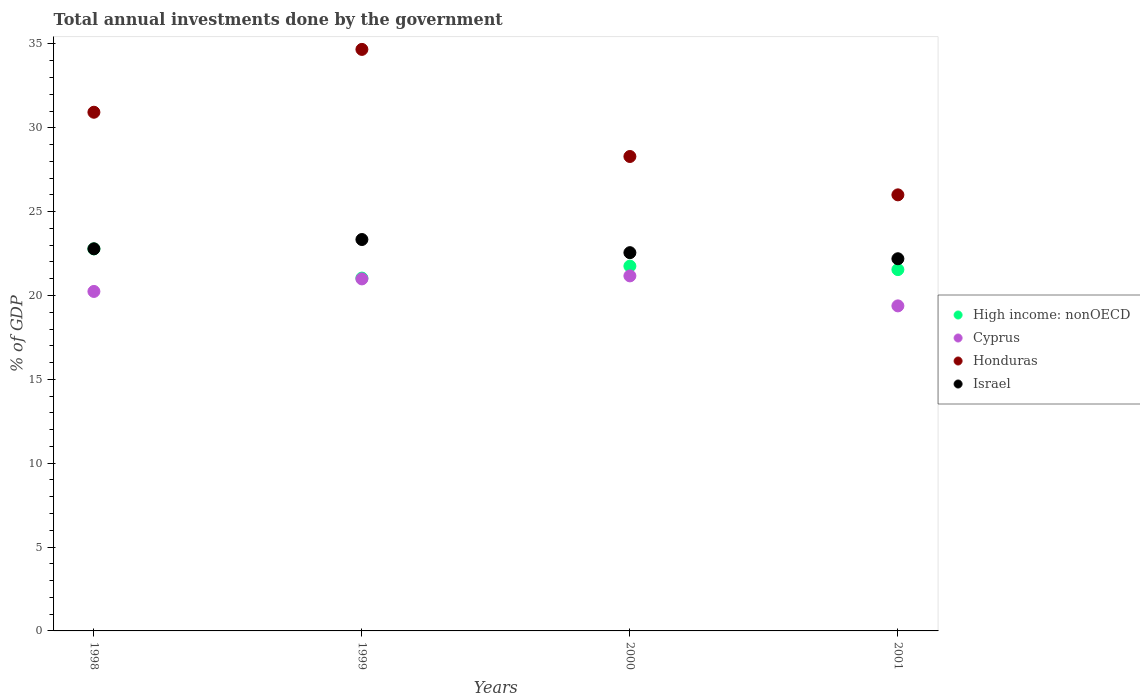What is the total annual investments done by the government in High income: nonOECD in 1999?
Ensure brevity in your answer.  21.04. Across all years, what is the maximum total annual investments done by the government in Israel?
Your answer should be very brief. 23.34. Across all years, what is the minimum total annual investments done by the government in Honduras?
Make the answer very short. 26. What is the total total annual investments done by the government in Israel in the graph?
Your response must be concise. 90.87. What is the difference between the total annual investments done by the government in Honduras in 1999 and that in 2001?
Make the answer very short. 8.67. What is the difference between the total annual investments done by the government in Honduras in 1998 and the total annual investments done by the government in Cyprus in 2000?
Your response must be concise. 9.76. What is the average total annual investments done by the government in Honduras per year?
Offer a terse response. 29.97. In the year 2000, what is the difference between the total annual investments done by the government in Honduras and total annual investments done by the government in Cyprus?
Provide a succinct answer. 7.12. In how many years, is the total annual investments done by the government in High income: nonOECD greater than 29 %?
Your response must be concise. 0. What is the ratio of the total annual investments done by the government in Honduras in 2000 to that in 2001?
Offer a terse response. 1.09. What is the difference between the highest and the second highest total annual investments done by the government in Honduras?
Your answer should be compact. 3.75. What is the difference between the highest and the lowest total annual investments done by the government in Israel?
Offer a terse response. 1.15. Is it the case that in every year, the sum of the total annual investments done by the government in High income: nonOECD and total annual investments done by the government in Israel  is greater than the sum of total annual investments done by the government in Honduras and total annual investments done by the government in Cyprus?
Your answer should be very brief. Yes. Does the total annual investments done by the government in High income: nonOECD monotonically increase over the years?
Offer a terse response. No. Is the total annual investments done by the government in Cyprus strictly greater than the total annual investments done by the government in Israel over the years?
Your response must be concise. No. Is the total annual investments done by the government in High income: nonOECD strictly less than the total annual investments done by the government in Israel over the years?
Offer a very short reply. Yes. How many years are there in the graph?
Provide a succinct answer. 4. What is the difference between two consecutive major ticks on the Y-axis?
Your answer should be very brief. 5. Are the values on the major ticks of Y-axis written in scientific E-notation?
Your response must be concise. No. What is the title of the graph?
Offer a terse response. Total annual investments done by the government. Does "Andorra" appear as one of the legend labels in the graph?
Your answer should be very brief. No. What is the label or title of the X-axis?
Offer a very short reply. Years. What is the label or title of the Y-axis?
Ensure brevity in your answer.  % of GDP. What is the % of GDP of High income: nonOECD in 1998?
Your answer should be very brief. 22.78. What is the % of GDP of Cyprus in 1998?
Your answer should be compact. 20.24. What is the % of GDP of Honduras in 1998?
Make the answer very short. 30.93. What is the % of GDP in Israel in 1998?
Make the answer very short. 22.78. What is the % of GDP in High income: nonOECD in 1999?
Give a very brief answer. 21.04. What is the % of GDP of Cyprus in 1999?
Your answer should be compact. 20.99. What is the % of GDP in Honduras in 1999?
Offer a terse response. 34.67. What is the % of GDP of Israel in 1999?
Give a very brief answer. 23.34. What is the % of GDP in High income: nonOECD in 2000?
Ensure brevity in your answer.  21.75. What is the % of GDP in Cyprus in 2000?
Ensure brevity in your answer.  21.17. What is the % of GDP of Honduras in 2000?
Provide a short and direct response. 28.29. What is the % of GDP in Israel in 2000?
Give a very brief answer. 22.55. What is the % of GDP in High income: nonOECD in 2001?
Your answer should be very brief. 21.54. What is the % of GDP in Cyprus in 2001?
Offer a very short reply. 19.38. What is the % of GDP in Honduras in 2001?
Keep it short and to the point. 26. What is the % of GDP of Israel in 2001?
Make the answer very short. 22.19. Across all years, what is the maximum % of GDP of High income: nonOECD?
Your answer should be very brief. 22.78. Across all years, what is the maximum % of GDP of Cyprus?
Give a very brief answer. 21.17. Across all years, what is the maximum % of GDP in Honduras?
Ensure brevity in your answer.  34.67. Across all years, what is the maximum % of GDP in Israel?
Provide a short and direct response. 23.34. Across all years, what is the minimum % of GDP in High income: nonOECD?
Your answer should be compact. 21.04. Across all years, what is the minimum % of GDP in Cyprus?
Your response must be concise. 19.38. Across all years, what is the minimum % of GDP of Honduras?
Your response must be concise. 26. Across all years, what is the minimum % of GDP of Israel?
Your response must be concise. 22.19. What is the total % of GDP in High income: nonOECD in the graph?
Ensure brevity in your answer.  87.11. What is the total % of GDP in Cyprus in the graph?
Offer a very short reply. 81.78. What is the total % of GDP in Honduras in the graph?
Offer a very short reply. 119.89. What is the total % of GDP in Israel in the graph?
Ensure brevity in your answer.  90.87. What is the difference between the % of GDP in High income: nonOECD in 1998 and that in 1999?
Provide a succinct answer. 1.74. What is the difference between the % of GDP of Cyprus in 1998 and that in 1999?
Your answer should be very brief. -0.75. What is the difference between the % of GDP in Honduras in 1998 and that in 1999?
Ensure brevity in your answer.  -3.75. What is the difference between the % of GDP in Israel in 1998 and that in 1999?
Your answer should be very brief. -0.55. What is the difference between the % of GDP in High income: nonOECD in 1998 and that in 2000?
Keep it short and to the point. 1.03. What is the difference between the % of GDP of Cyprus in 1998 and that in 2000?
Keep it short and to the point. -0.93. What is the difference between the % of GDP of Honduras in 1998 and that in 2000?
Ensure brevity in your answer.  2.64. What is the difference between the % of GDP of Israel in 1998 and that in 2000?
Ensure brevity in your answer.  0.23. What is the difference between the % of GDP of High income: nonOECD in 1998 and that in 2001?
Give a very brief answer. 1.23. What is the difference between the % of GDP of Cyprus in 1998 and that in 2001?
Provide a short and direct response. 0.86. What is the difference between the % of GDP in Honduras in 1998 and that in 2001?
Offer a terse response. 4.93. What is the difference between the % of GDP in Israel in 1998 and that in 2001?
Provide a succinct answer. 0.59. What is the difference between the % of GDP in High income: nonOECD in 1999 and that in 2000?
Keep it short and to the point. -0.71. What is the difference between the % of GDP of Cyprus in 1999 and that in 2000?
Give a very brief answer. -0.18. What is the difference between the % of GDP in Honduras in 1999 and that in 2000?
Give a very brief answer. 6.39. What is the difference between the % of GDP in Israel in 1999 and that in 2000?
Give a very brief answer. 0.78. What is the difference between the % of GDP in High income: nonOECD in 1999 and that in 2001?
Make the answer very short. -0.51. What is the difference between the % of GDP of Cyprus in 1999 and that in 2001?
Provide a succinct answer. 1.61. What is the difference between the % of GDP of Honduras in 1999 and that in 2001?
Keep it short and to the point. 8.67. What is the difference between the % of GDP in Israel in 1999 and that in 2001?
Provide a short and direct response. 1.15. What is the difference between the % of GDP in High income: nonOECD in 2000 and that in 2001?
Make the answer very short. 0.21. What is the difference between the % of GDP in Cyprus in 2000 and that in 2001?
Ensure brevity in your answer.  1.79. What is the difference between the % of GDP of Honduras in 2000 and that in 2001?
Ensure brevity in your answer.  2.29. What is the difference between the % of GDP of Israel in 2000 and that in 2001?
Offer a terse response. 0.36. What is the difference between the % of GDP in High income: nonOECD in 1998 and the % of GDP in Cyprus in 1999?
Make the answer very short. 1.79. What is the difference between the % of GDP of High income: nonOECD in 1998 and the % of GDP of Honduras in 1999?
Your answer should be compact. -11.9. What is the difference between the % of GDP in High income: nonOECD in 1998 and the % of GDP in Israel in 1999?
Keep it short and to the point. -0.56. What is the difference between the % of GDP of Cyprus in 1998 and the % of GDP of Honduras in 1999?
Your response must be concise. -14.43. What is the difference between the % of GDP in Cyprus in 1998 and the % of GDP in Israel in 1999?
Provide a succinct answer. -3.1. What is the difference between the % of GDP in Honduras in 1998 and the % of GDP in Israel in 1999?
Give a very brief answer. 7.59. What is the difference between the % of GDP in High income: nonOECD in 1998 and the % of GDP in Cyprus in 2000?
Offer a very short reply. 1.61. What is the difference between the % of GDP in High income: nonOECD in 1998 and the % of GDP in Honduras in 2000?
Keep it short and to the point. -5.51. What is the difference between the % of GDP in High income: nonOECD in 1998 and the % of GDP in Israel in 2000?
Offer a very short reply. 0.22. What is the difference between the % of GDP of Cyprus in 1998 and the % of GDP of Honduras in 2000?
Your answer should be very brief. -8.05. What is the difference between the % of GDP in Cyprus in 1998 and the % of GDP in Israel in 2000?
Offer a terse response. -2.31. What is the difference between the % of GDP in Honduras in 1998 and the % of GDP in Israel in 2000?
Your answer should be very brief. 8.37. What is the difference between the % of GDP in High income: nonOECD in 1998 and the % of GDP in Cyprus in 2001?
Make the answer very short. 3.4. What is the difference between the % of GDP in High income: nonOECD in 1998 and the % of GDP in Honduras in 2001?
Your response must be concise. -3.22. What is the difference between the % of GDP in High income: nonOECD in 1998 and the % of GDP in Israel in 2001?
Your answer should be compact. 0.59. What is the difference between the % of GDP in Cyprus in 1998 and the % of GDP in Honduras in 2001?
Offer a terse response. -5.76. What is the difference between the % of GDP of Cyprus in 1998 and the % of GDP of Israel in 2001?
Make the answer very short. -1.95. What is the difference between the % of GDP in Honduras in 1998 and the % of GDP in Israel in 2001?
Provide a short and direct response. 8.74. What is the difference between the % of GDP of High income: nonOECD in 1999 and the % of GDP of Cyprus in 2000?
Your answer should be very brief. -0.13. What is the difference between the % of GDP of High income: nonOECD in 1999 and the % of GDP of Honduras in 2000?
Give a very brief answer. -7.25. What is the difference between the % of GDP of High income: nonOECD in 1999 and the % of GDP of Israel in 2000?
Your response must be concise. -1.52. What is the difference between the % of GDP of Cyprus in 1999 and the % of GDP of Honduras in 2000?
Keep it short and to the point. -7.3. What is the difference between the % of GDP of Cyprus in 1999 and the % of GDP of Israel in 2000?
Keep it short and to the point. -1.56. What is the difference between the % of GDP of Honduras in 1999 and the % of GDP of Israel in 2000?
Provide a short and direct response. 12.12. What is the difference between the % of GDP of High income: nonOECD in 1999 and the % of GDP of Cyprus in 2001?
Keep it short and to the point. 1.66. What is the difference between the % of GDP of High income: nonOECD in 1999 and the % of GDP of Honduras in 2001?
Ensure brevity in your answer.  -4.96. What is the difference between the % of GDP in High income: nonOECD in 1999 and the % of GDP in Israel in 2001?
Offer a very short reply. -1.15. What is the difference between the % of GDP in Cyprus in 1999 and the % of GDP in Honduras in 2001?
Give a very brief answer. -5.01. What is the difference between the % of GDP in Cyprus in 1999 and the % of GDP in Israel in 2001?
Provide a short and direct response. -1.2. What is the difference between the % of GDP of Honduras in 1999 and the % of GDP of Israel in 2001?
Provide a succinct answer. 12.48. What is the difference between the % of GDP of High income: nonOECD in 2000 and the % of GDP of Cyprus in 2001?
Offer a very short reply. 2.37. What is the difference between the % of GDP of High income: nonOECD in 2000 and the % of GDP of Honduras in 2001?
Provide a short and direct response. -4.25. What is the difference between the % of GDP in High income: nonOECD in 2000 and the % of GDP in Israel in 2001?
Keep it short and to the point. -0.44. What is the difference between the % of GDP of Cyprus in 2000 and the % of GDP of Honduras in 2001?
Offer a terse response. -4.83. What is the difference between the % of GDP in Cyprus in 2000 and the % of GDP in Israel in 2001?
Your answer should be compact. -1.02. What is the difference between the % of GDP in Honduras in 2000 and the % of GDP in Israel in 2001?
Provide a succinct answer. 6.1. What is the average % of GDP in High income: nonOECD per year?
Your answer should be very brief. 21.78. What is the average % of GDP in Cyprus per year?
Offer a very short reply. 20.45. What is the average % of GDP in Honduras per year?
Keep it short and to the point. 29.97. What is the average % of GDP in Israel per year?
Make the answer very short. 22.72. In the year 1998, what is the difference between the % of GDP in High income: nonOECD and % of GDP in Cyprus?
Make the answer very short. 2.54. In the year 1998, what is the difference between the % of GDP of High income: nonOECD and % of GDP of Honduras?
Provide a succinct answer. -8.15. In the year 1998, what is the difference between the % of GDP of High income: nonOECD and % of GDP of Israel?
Your answer should be very brief. -0.01. In the year 1998, what is the difference between the % of GDP in Cyprus and % of GDP in Honduras?
Offer a terse response. -10.69. In the year 1998, what is the difference between the % of GDP of Cyprus and % of GDP of Israel?
Offer a terse response. -2.54. In the year 1998, what is the difference between the % of GDP in Honduras and % of GDP in Israel?
Give a very brief answer. 8.14. In the year 1999, what is the difference between the % of GDP in High income: nonOECD and % of GDP in Cyprus?
Provide a short and direct response. 0.05. In the year 1999, what is the difference between the % of GDP in High income: nonOECD and % of GDP in Honduras?
Offer a very short reply. -13.64. In the year 1999, what is the difference between the % of GDP in High income: nonOECD and % of GDP in Israel?
Provide a short and direct response. -2.3. In the year 1999, what is the difference between the % of GDP of Cyprus and % of GDP of Honduras?
Offer a very short reply. -13.68. In the year 1999, what is the difference between the % of GDP of Cyprus and % of GDP of Israel?
Offer a very short reply. -2.35. In the year 1999, what is the difference between the % of GDP of Honduras and % of GDP of Israel?
Your response must be concise. 11.34. In the year 2000, what is the difference between the % of GDP of High income: nonOECD and % of GDP of Cyprus?
Offer a terse response. 0.58. In the year 2000, what is the difference between the % of GDP in High income: nonOECD and % of GDP in Honduras?
Your answer should be compact. -6.54. In the year 2000, what is the difference between the % of GDP in High income: nonOECD and % of GDP in Israel?
Your answer should be compact. -0.8. In the year 2000, what is the difference between the % of GDP in Cyprus and % of GDP in Honduras?
Provide a short and direct response. -7.12. In the year 2000, what is the difference between the % of GDP of Cyprus and % of GDP of Israel?
Your answer should be compact. -1.38. In the year 2000, what is the difference between the % of GDP in Honduras and % of GDP in Israel?
Give a very brief answer. 5.73. In the year 2001, what is the difference between the % of GDP of High income: nonOECD and % of GDP of Cyprus?
Provide a succinct answer. 2.16. In the year 2001, what is the difference between the % of GDP of High income: nonOECD and % of GDP of Honduras?
Your answer should be compact. -4.46. In the year 2001, what is the difference between the % of GDP in High income: nonOECD and % of GDP in Israel?
Offer a very short reply. -0.65. In the year 2001, what is the difference between the % of GDP of Cyprus and % of GDP of Honduras?
Keep it short and to the point. -6.62. In the year 2001, what is the difference between the % of GDP of Cyprus and % of GDP of Israel?
Your answer should be compact. -2.81. In the year 2001, what is the difference between the % of GDP in Honduras and % of GDP in Israel?
Provide a succinct answer. 3.81. What is the ratio of the % of GDP in High income: nonOECD in 1998 to that in 1999?
Give a very brief answer. 1.08. What is the ratio of the % of GDP in Cyprus in 1998 to that in 1999?
Your answer should be compact. 0.96. What is the ratio of the % of GDP of Honduras in 1998 to that in 1999?
Your answer should be very brief. 0.89. What is the ratio of the % of GDP in Israel in 1998 to that in 1999?
Your answer should be compact. 0.98. What is the ratio of the % of GDP in High income: nonOECD in 1998 to that in 2000?
Offer a terse response. 1.05. What is the ratio of the % of GDP of Cyprus in 1998 to that in 2000?
Give a very brief answer. 0.96. What is the ratio of the % of GDP of Honduras in 1998 to that in 2000?
Offer a very short reply. 1.09. What is the ratio of the % of GDP in Israel in 1998 to that in 2000?
Provide a succinct answer. 1.01. What is the ratio of the % of GDP of High income: nonOECD in 1998 to that in 2001?
Your answer should be very brief. 1.06. What is the ratio of the % of GDP in Cyprus in 1998 to that in 2001?
Keep it short and to the point. 1.04. What is the ratio of the % of GDP of Honduras in 1998 to that in 2001?
Your answer should be compact. 1.19. What is the ratio of the % of GDP of Israel in 1998 to that in 2001?
Offer a terse response. 1.03. What is the ratio of the % of GDP of High income: nonOECD in 1999 to that in 2000?
Offer a terse response. 0.97. What is the ratio of the % of GDP in Honduras in 1999 to that in 2000?
Your answer should be compact. 1.23. What is the ratio of the % of GDP of Israel in 1999 to that in 2000?
Make the answer very short. 1.03. What is the ratio of the % of GDP of High income: nonOECD in 1999 to that in 2001?
Keep it short and to the point. 0.98. What is the ratio of the % of GDP in Cyprus in 1999 to that in 2001?
Your answer should be very brief. 1.08. What is the ratio of the % of GDP in Honduras in 1999 to that in 2001?
Offer a terse response. 1.33. What is the ratio of the % of GDP of Israel in 1999 to that in 2001?
Your answer should be very brief. 1.05. What is the ratio of the % of GDP of High income: nonOECD in 2000 to that in 2001?
Ensure brevity in your answer.  1.01. What is the ratio of the % of GDP of Cyprus in 2000 to that in 2001?
Keep it short and to the point. 1.09. What is the ratio of the % of GDP of Honduras in 2000 to that in 2001?
Give a very brief answer. 1.09. What is the ratio of the % of GDP of Israel in 2000 to that in 2001?
Offer a very short reply. 1.02. What is the difference between the highest and the second highest % of GDP in High income: nonOECD?
Make the answer very short. 1.03. What is the difference between the highest and the second highest % of GDP in Cyprus?
Offer a terse response. 0.18. What is the difference between the highest and the second highest % of GDP in Honduras?
Offer a terse response. 3.75. What is the difference between the highest and the second highest % of GDP in Israel?
Your answer should be very brief. 0.55. What is the difference between the highest and the lowest % of GDP in High income: nonOECD?
Offer a terse response. 1.74. What is the difference between the highest and the lowest % of GDP in Cyprus?
Make the answer very short. 1.79. What is the difference between the highest and the lowest % of GDP in Honduras?
Your answer should be very brief. 8.67. What is the difference between the highest and the lowest % of GDP of Israel?
Give a very brief answer. 1.15. 